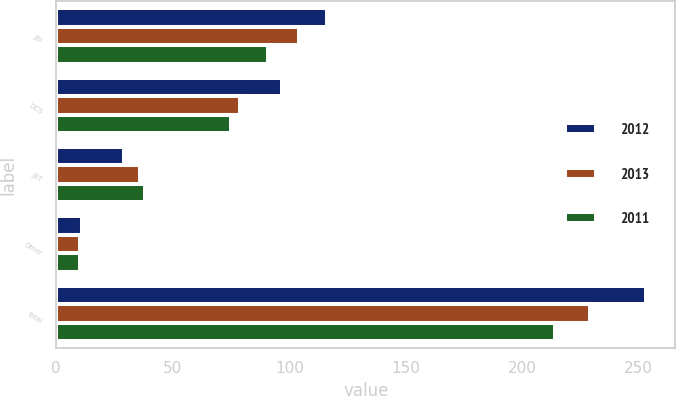Convert chart to OTSL. <chart><loc_0><loc_0><loc_500><loc_500><stacked_bar_chart><ecel><fcel>JBI<fcel>DCS<fcel>JBT<fcel>Other<fcel>Total<nl><fcel>2012<fcel>116<fcel>97<fcel>29<fcel>11<fcel>253<nl><fcel>2013<fcel>104<fcel>79<fcel>36<fcel>10<fcel>229<nl><fcel>2011<fcel>91<fcel>75<fcel>38<fcel>10<fcel>214<nl></chart> 